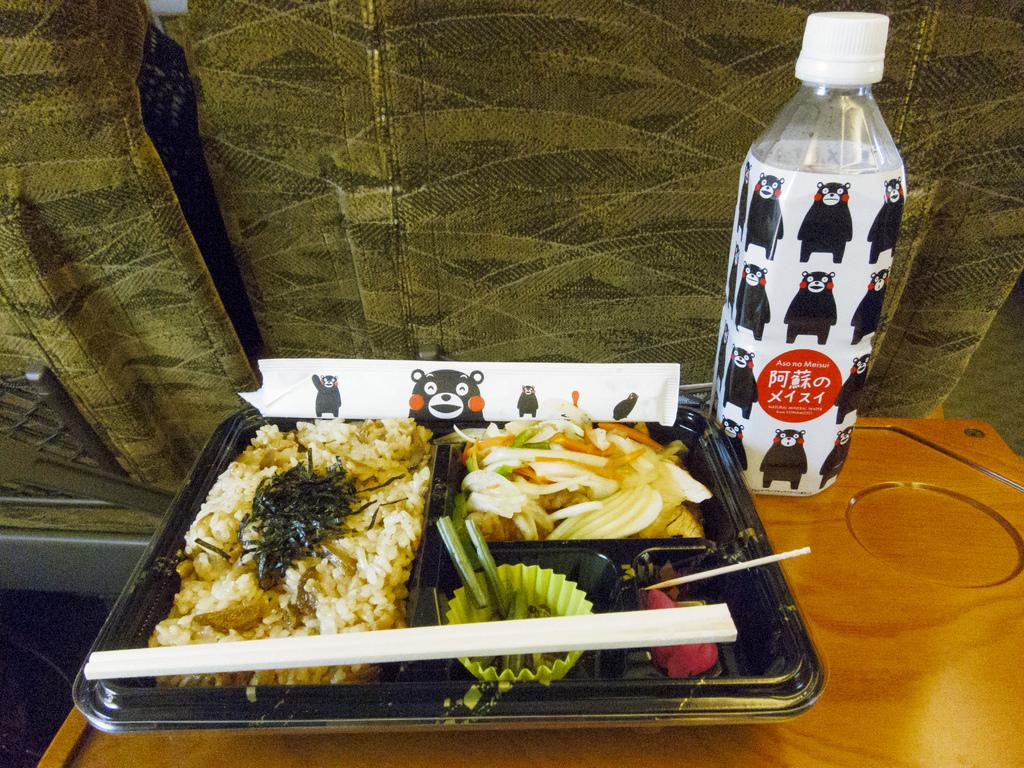<image>
Summarize the visual content of the image. A to-go Asian meal sits on a surface next to a bottle that has Korean writing along with a phrase that starts with the word aso. 